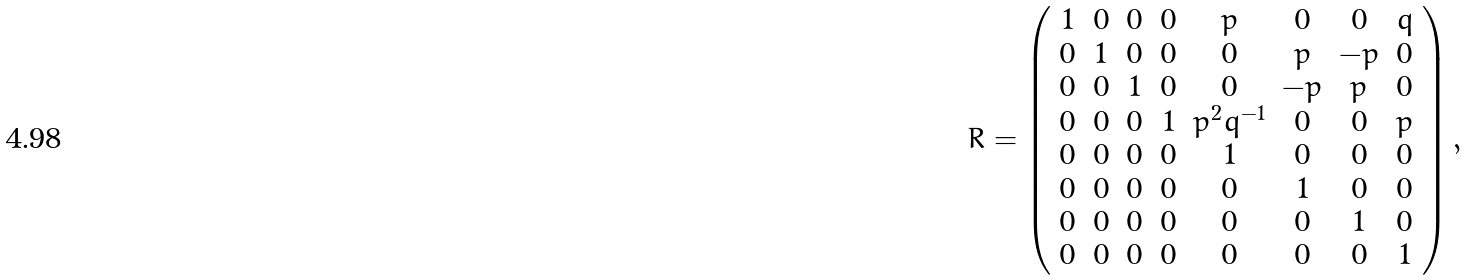Convert formula to latex. <formula><loc_0><loc_0><loc_500><loc_500>R = \left ( \begin{array} { c c c c c c c c } 1 & 0 & 0 & 0 & p & 0 & 0 & q \\ 0 & 1 & 0 & 0 & 0 & p & - p & 0 \\ 0 & 0 & 1 & 0 & 0 & - p & p & 0 \\ 0 & 0 & 0 & 1 & p ^ { 2 } q ^ { - 1 } & 0 & 0 & p \\ 0 & 0 & 0 & 0 & 1 & 0 & 0 & 0 \\ 0 & 0 & 0 & 0 & 0 & 1 & 0 & 0 \\ 0 & 0 & 0 & 0 & 0 & 0 & 1 & 0 \\ 0 & 0 & 0 & 0 & 0 & 0 & 0 & 1 \end{array} \right ) ,</formula> 